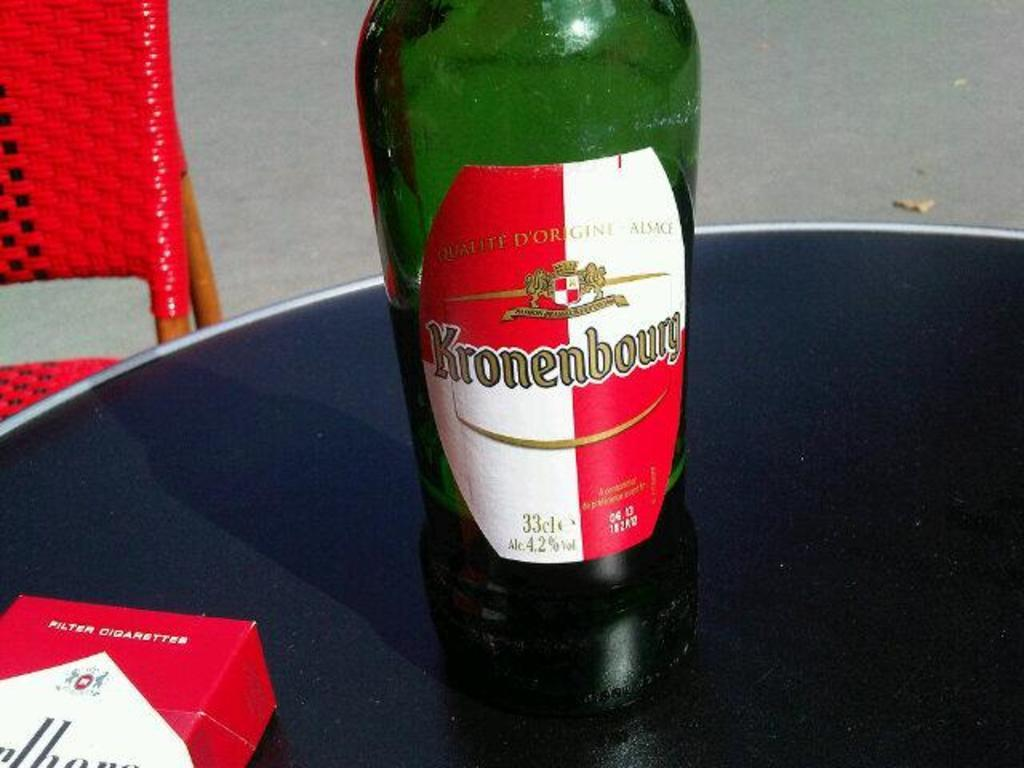<image>
Present a compact description of the photo's key features. a green bottle with a white and red label that says 'kronenbourg' on it 